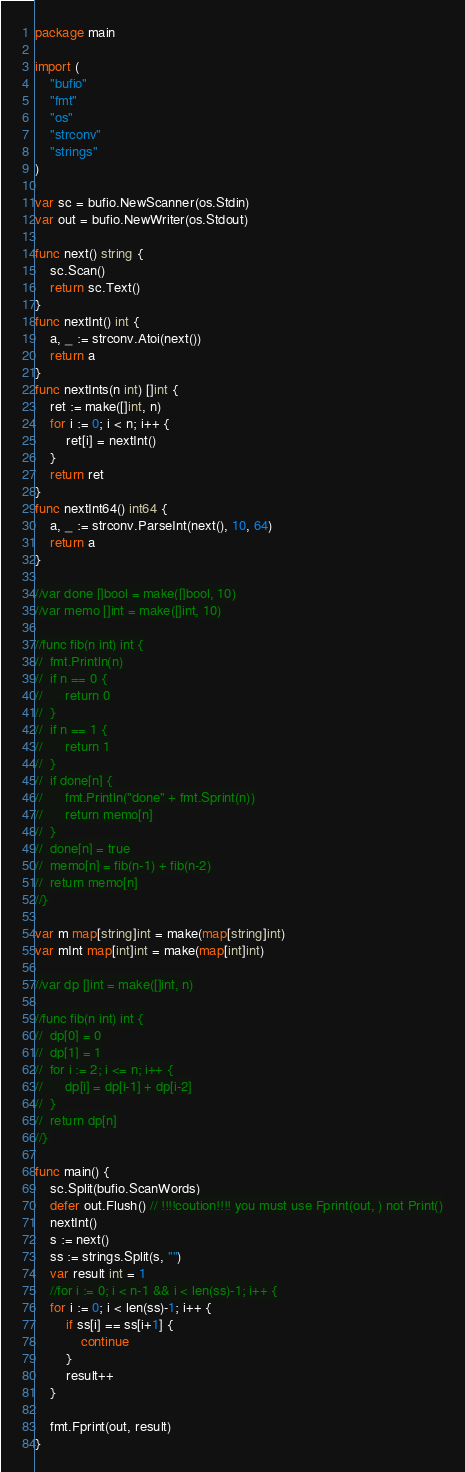<code> <loc_0><loc_0><loc_500><loc_500><_Go_>package main

import (
	"bufio"
	"fmt"
	"os"
	"strconv"
	"strings"
)

var sc = bufio.NewScanner(os.Stdin)
var out = bufio.NewWriter(os.Stdout)

func next() string {
	sc.Scan()
	return sc.Text()
}
func nextInt() int {
	a, _ := strconv.Atoi(next())
	return a
}
func nextInts(n int) []int {
	ret := make([]int, n)
	for i := 0; i < n; i++ {
		ret[i] = nextInt()
	}
	return ret
}
func nextInt64() int64 {
	a, _ := strconv.ParseInt(next(), 10, 64)
	return a
}

//var done []bool = make([]bool, 10)
//var memo []int = make([]int, 10)

//func fib(n int) int {
//	fmt.Println(n)
//	if n == 0 {
//		return 0
//	}
//	if n == 1 {
//		return 1
//	}
//	if done[n] {
//		fmt.Println("done" + fmt.Sprint(n))
//		return memo[n]
//	}
//	done[n] = true
//	memo[n] = fib(n-1) + fib(n-2)
//	return memo[n]
//}

var m map[string]int = make(map[string]int)
var mInt map[int]int = make(map[int]int)

//var dp []int = make([]int, n)

//func fib(n int) int {
//	dp[0] = 0
//	dp[1] = 1
//	for i := 2; i <= n; i++ {
//		dp[i] = dp[i-1] + dp[i-2]
//	}
//	return dp[n]
//}

func main() {
	sc.Split(bufio.ScanWords)
	defer out.Flush() // !!!!coution!!!! you must use Fprint(out, ) not Print()
	nextInt()
	s := next()
	ss := strings.Split(s, "")
	var result int = 1
	//for i := 0; i < n-1 && i < len(ss)-1; i++ {
	for i := 0; i < len(ss)-1; i++ {
		if ss[i] == ss[i+1] {
			continue
		}
		result++
	}

	fmt.Fprint(out, result)
}
</code> 